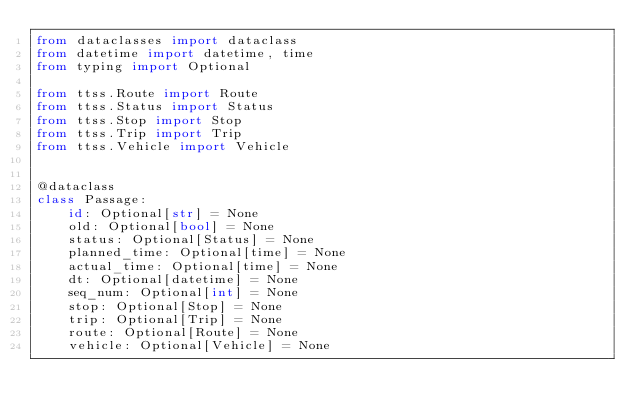<code> <loc_0><loc_0><loc_500><loc_500><_Python_>from dataclasses import dataclass
from datetime import datetime, time
from typing import Optional

from ttss.Route import Route
from ttss.Status import Status
from ttss.Stop import Stop
from ttss.Trip import Trip
from ttss.Vehicle import Vehicle


@dataclass
class Passage:
    id: Optional[str] = None
    old: Optional[bool] = None
    status: Optional[Status] = None
    planned_time: Optional[time] = None
    actual_time: Optional[time] = None
    dt: Optional[datetime] = None
    seq_num: Optional[int] = None
    stop: Optional[Stop] = None
    trip: Optional[Trip] = None
    route: Optional[Route] = None
    vehicle: Optional[Vehicle] = None
</code> 